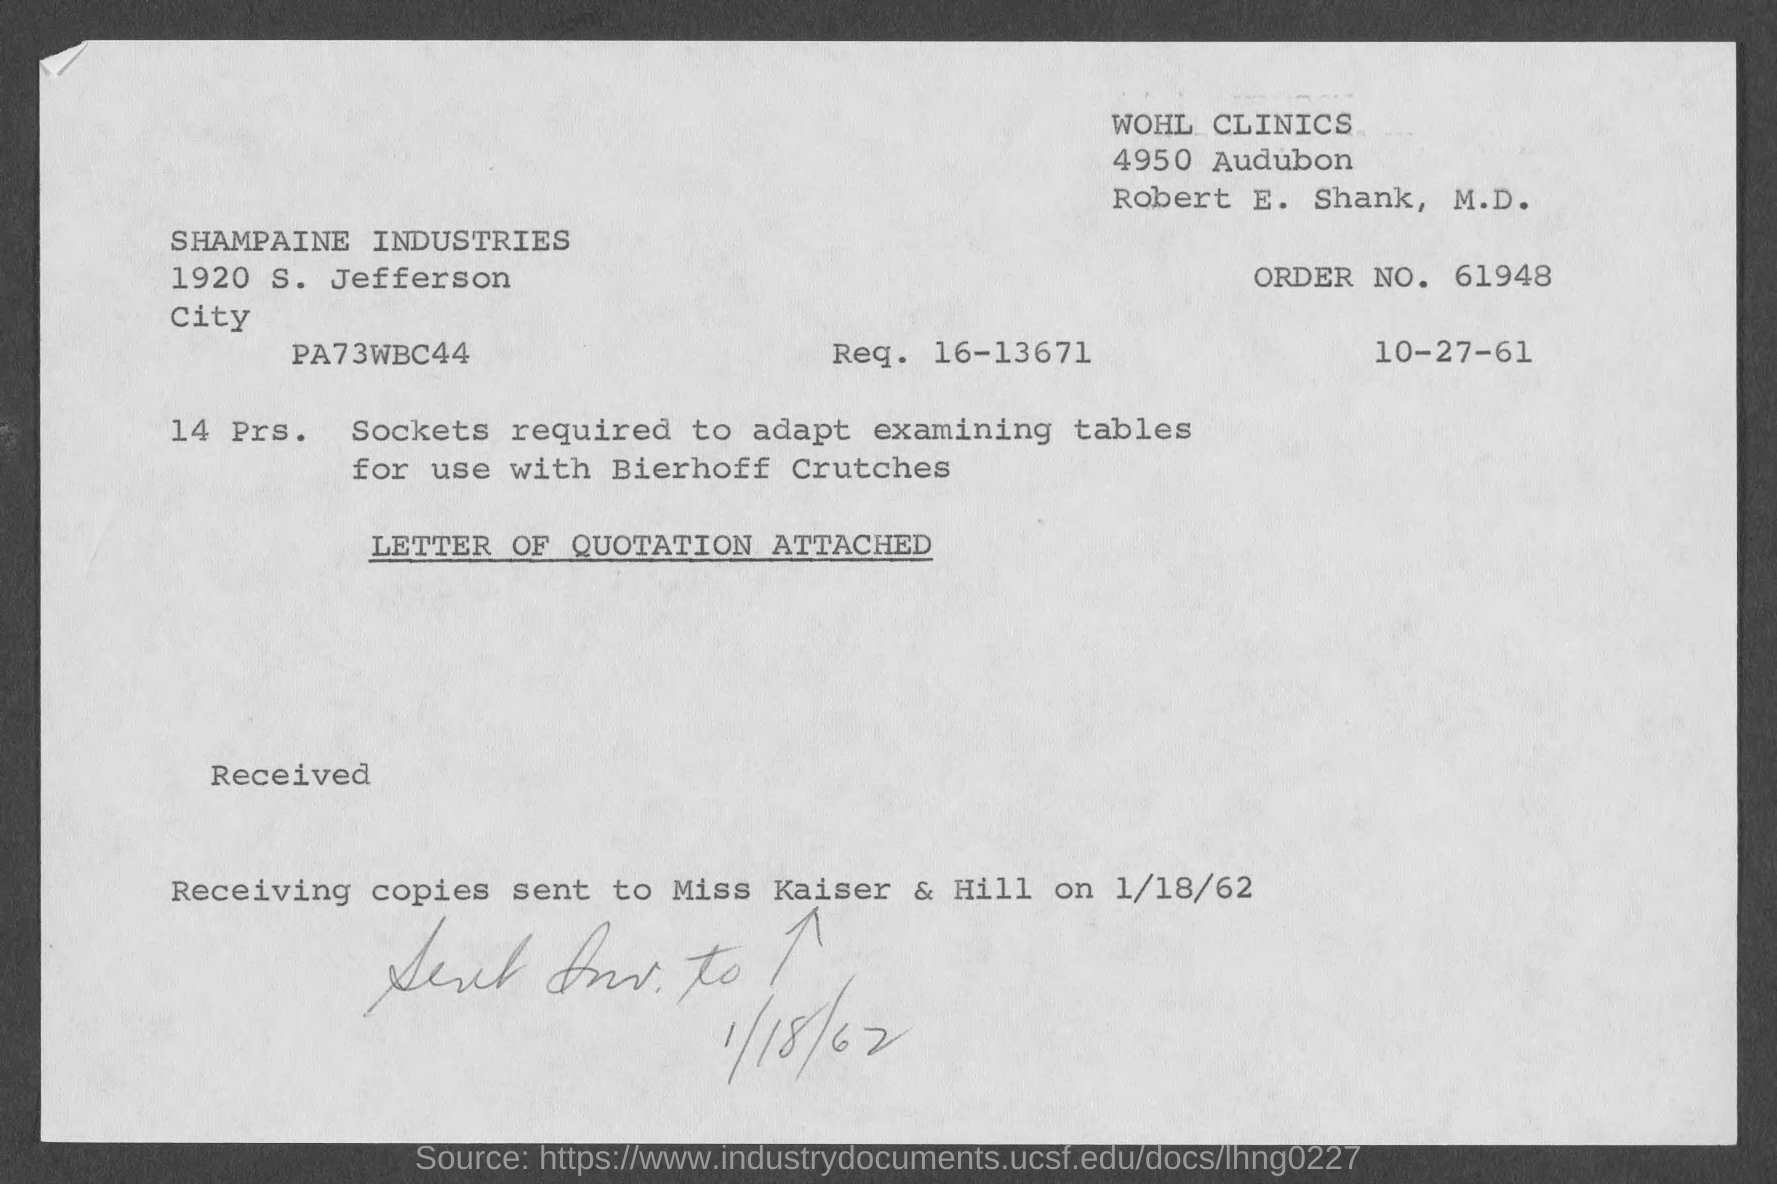Indicate a few pertinent items in this graphic. The order number is 61948... 